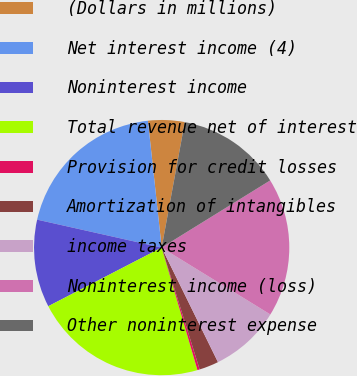Convert chart to OTSL. <chart><loc_0><loc_0><loc_500><loc_500><pie_chart><fcel>(Dollars in millions)<fcel>Net interest income (4)<fcel>Noninterest income<fcel>Total revenue net of interest<fcel>Provision for credit losses<fcel>Amortization of intangibles<fcel>income taxes<fcel>Noninterest income (loss)<fcel>Other noninterest expense<nl><fcel>4.62%<fcel>19.77%<fcel>11.11%<fcel>21.93%<fcel>0.29%<fcel>2.46%<fcel>8.95%<fcel>17.6%<fcel>13.28%<nl></chart> 